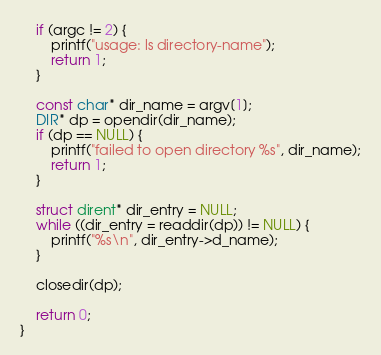Convert code to text. <code><loc_0><loc_0><loc_500><loc_500><_C_>    if (argc != 2) {
        printf("usage: ls directory-name");
        return 1;
    }

    const char* dir_name = argv[1];
    DIR* dp = opendir(dir_name);
    if (dp == NULL) {
        printf("failed to open directory %s", dir_name);
        return 1;
    }

    struct dirent* dir_entry = NULL;
    while ((dir_entry = readdir(dp)) != NULL) {
        printf("%s\n", dir_entry->d_name);
    }

    closedir(dp);

    return 0;
}
</code> 